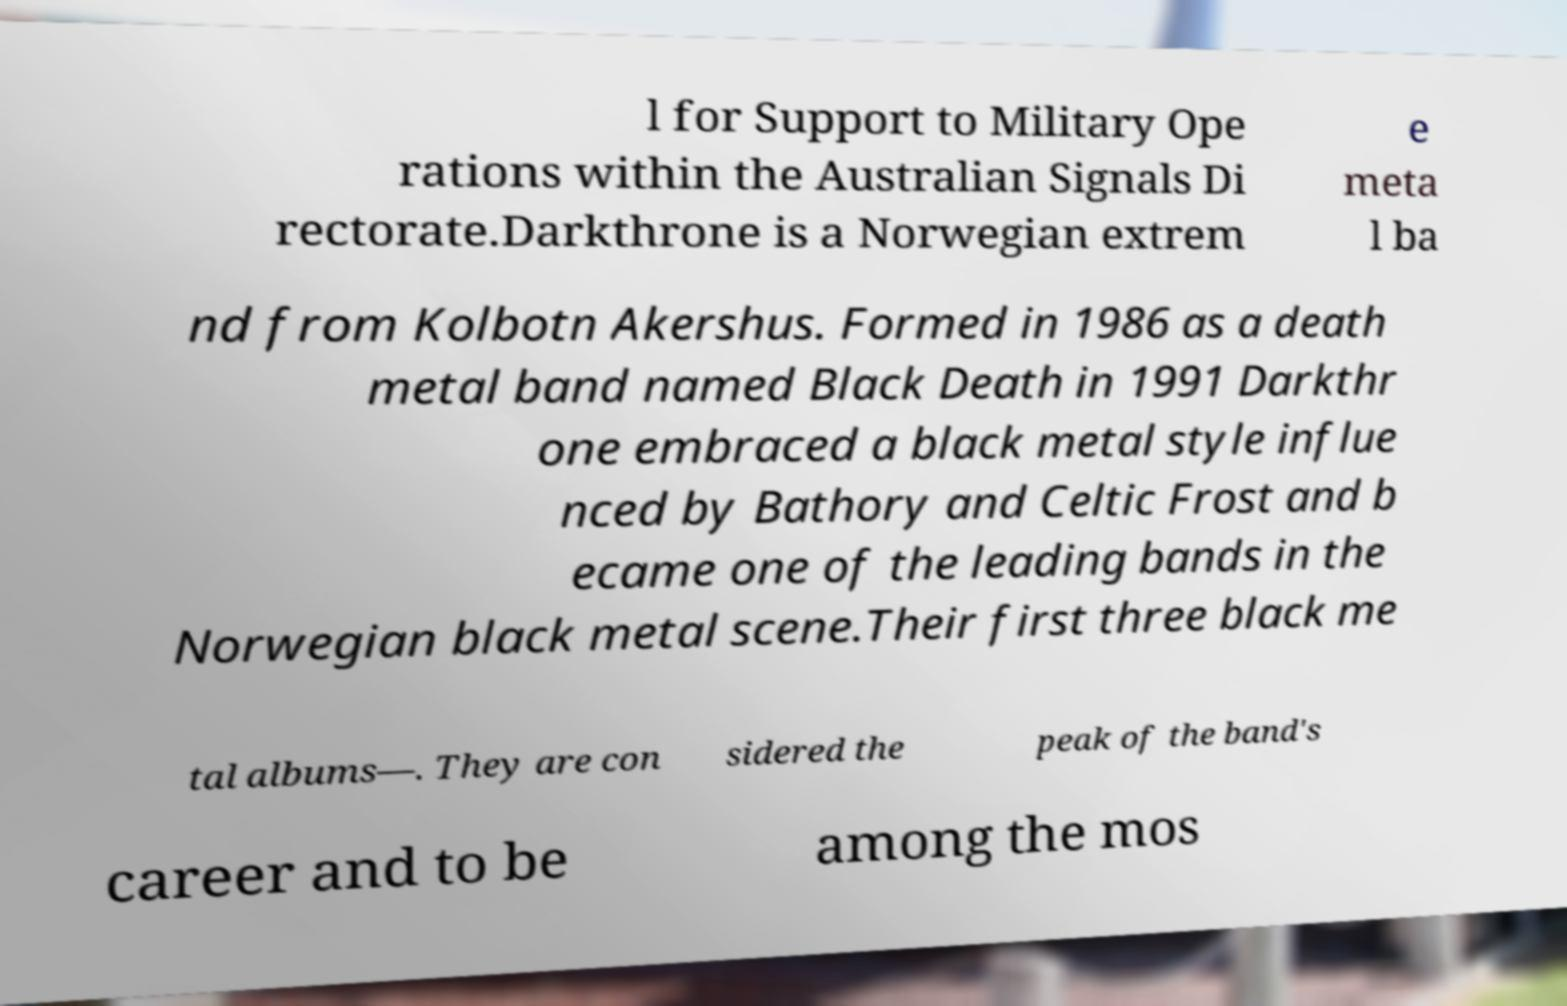Can you read and provide the text displayed in the image?This photo seems to have some interesting text. Can you extract and type it out for me? l for Support to Military Ope rations within the Australian Signals Di rectorate.Darkthrone is a Norwegian extrem e meta l ba nd from Kolbotn Akershus. Formed in 1986 as a death metal band named Black Death in 1991 Darkthr one embraced a black metal style influe nced by Bathory and Celtic Frost and b ecame one of the leading bands in the Norwegian black metal scene.Their first three black me tal albums—. They are con sidered the peak of the band's career and to be among the mos 